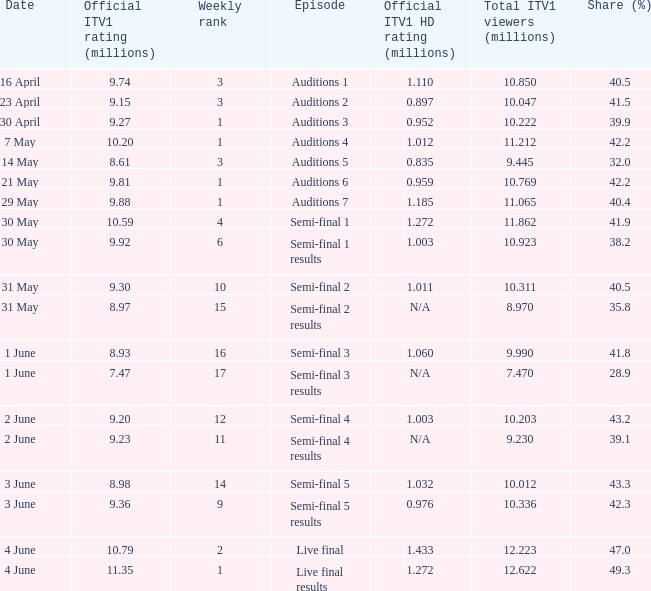What was the share (%) for the Semi-Final 2 episode?  40.5. 